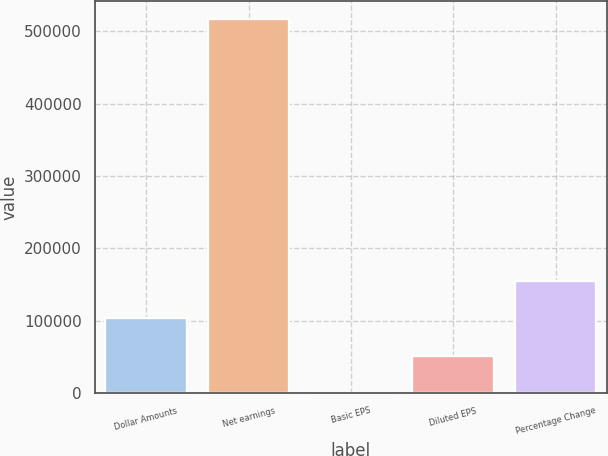Convert chart. <chart><loc_0><loc_0><loc_500><loc_500><bar_chart><fcel>Dollar Amounts<fcel>Net earnings<fcel>Basic EPS<fcel>Diluted EPS<fcel>Percentage Change<nl><fcel>103274<fcel>516361<fcel>1.77<fcel>51637.7<fcel>154910<nl></chart> 